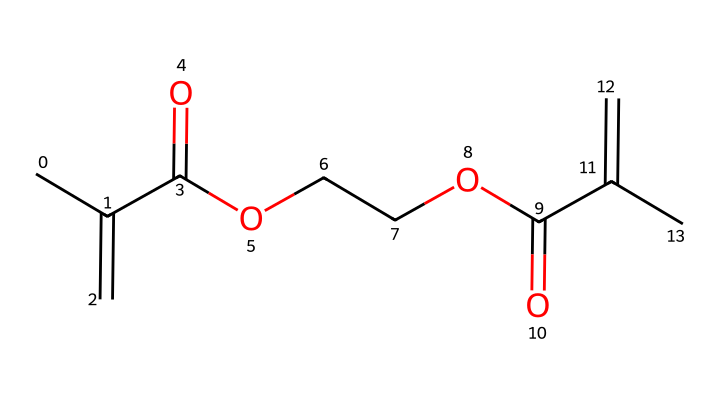What type of functional groups are present in this chemical? The chemical contains carboxylic acid groups (indicated by -COOH) and ether groups (indicated by -O-). Both groups can be identified through the functional group patterns present in the structural formula.
Answer: carboxylic acid and ether How many carbon atoms are in the chemical structure? By counting the "C" (carbon) symbols in the SMILES representation, we can identify that there are a total of 8 carbon atoms in this chemical.
Answer: 8 What is the central role of this chemical in nail polish? As a photoresist or UV-curable resin, this chemical is primarily used for forming a durable and glossy finish in nail polish, thanks to its ability to cure when exposed to UV light.
Answer: forming a durable finish How many double bonds are present in the structure? The structure contains two double bonds denoted by the "=" symbols between carbon atoms, indicating the presence of alkenes. Therefore, we can conclude that there are two double bonds in total.
Answer: 2 What does "UV-curable" indicate about this chemical? "UV-curable" signifies that this chemical can undergo a cross-linking reaction and harden upon exposure to ultraviolet light, which is essential for the functionality of nail polish in providing a quick-drying finish.
Answer: has a cross-linking reaction Which part of the chemical is responsible for its adhesive properties? The presence of carboxylic acid groups in the structure contributes to the adhesive properties of the chemical, enabling it to bond well with other materials on the nails.
Answer: carboxylic acid groups 